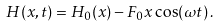Convert formula to latex. <formula><loc_0><loc_0><loc_500><loc_500>H ( x , t ) = H _ { 0 } ( x ) - F _ { 0 } x \cos ( \omega t ) \, .</formula> 